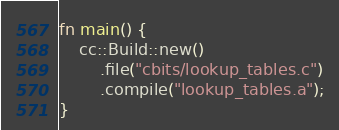<code> <loc_0><loc_0><loc_500><loc_500><_Rust_>fn main() {
    cc::Build::new()
        .file("cbits/lookup_tables.c")
        .compile("lookup_tables.a");
}
</code> 